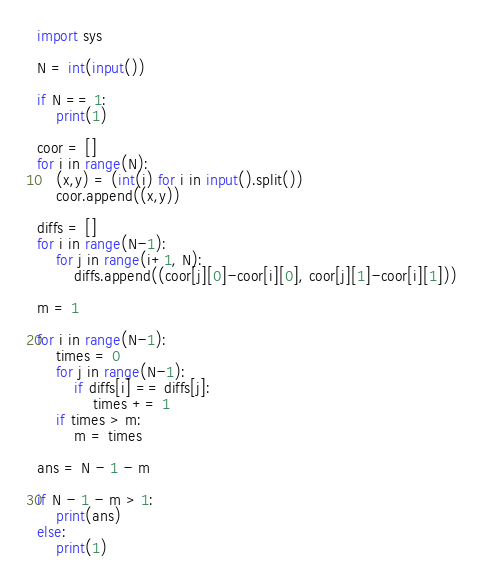Convert code to text. <code><loc_0><loc_0><loc_500><loc_500><_Python_>import sys

N = int(input())

if N == 1:
    print(1)

coor = []
for i in range(N):
    (x,y) = (int(i) for i in input().split())
    coor.append((x,y))
    
diffs = []
for i in range(N-1):
    for j in range(i+1, N):
        diffs.append((coor[j][0]-coor[i][0], coor[j][1]-coor[i][1]))
    
m = 1

for i in range(N-1):
    times = 0
    for j in range(N-1):
        if diffs[i] == diffs[j]:
            times += 1
    if times > m:
        m = times

ans = N - 1 - m   

if N - 1 - m > 1:
    print(ans)
else:
    print(1)
</code> 